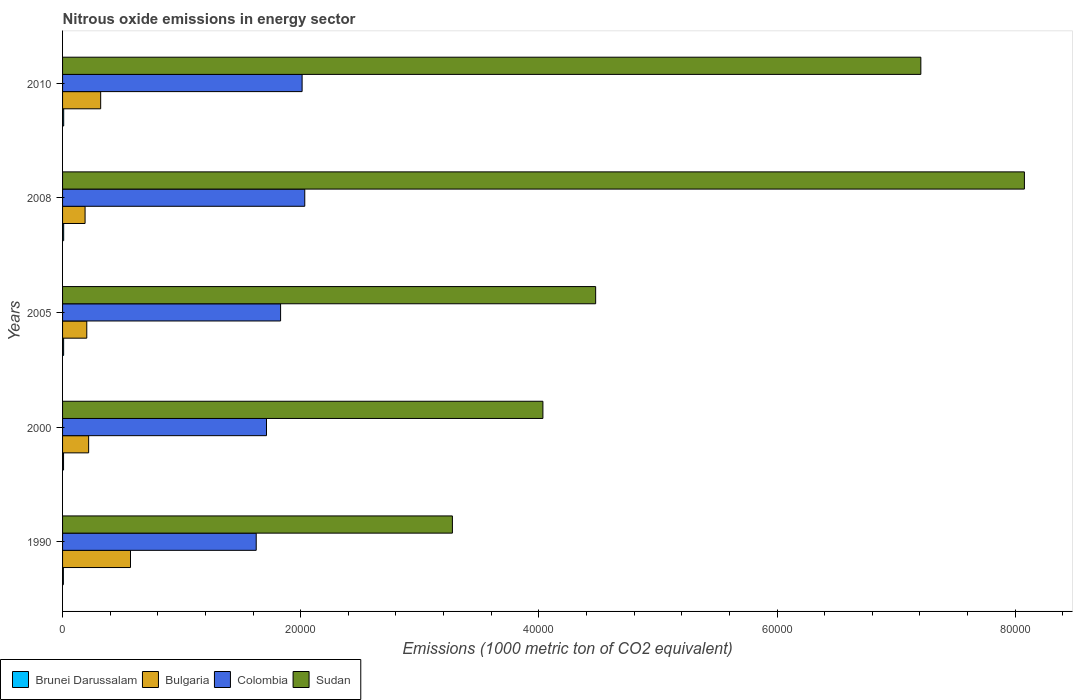How many bars are there on the 5th tick from the bottom?
Provide a short and direct response. 4. What is the amount of nitrous oxide emitted in Brunei Darussalam in 2005?
Provide a short and direct response. 88.9. Across all years, what is the maximum amount of nitrous oxide emitted in Colombia?
Provide a succinct answer. 2.03e+04. Across all years, what is the minimum amount of nitrous oxide emitted in Sudan?
Provide a succinct answer. 3.27e+04. In which year was the amount of nitrous oxide emitted in Colombia minimum?
Provide a succinct answer. 1990. What is the total amount of nitrous oxide emitted in Colombia in the graph?
Provide a succinct answer. 9.22e+04. What is the difference between the amount of nitrous oxide emitted in Sudan in 2000 and that in 2010?
Give a very brief answer. -3.17e+04. What is the difference between the amount of nitrous oxide emitted in Sudan in 1990 and the amount of nitrous oxide emitted in Colombia in 2008?
Make the answer very short. 1.24e+04. What is the average amount of nitrous oxide emitted in Sudan per year?
Give a very brief answer. 5.41e+04. In the year 1990, what is the difference between the amount of nitrous oxide emitted in Sudan and amount of nitrous oxide emitted in Colombia?
Provide a succinct answer. 1.65e+04. What is the ratio of the amount of nitrous oxide emitted in Sudan in 2005 to that in 2010?
Provide a succinct answer. 0.62. Is the difference between the amount of nitrous oxide emitted in Sudan in 2008 and 2010 greater than the difference between the amount of nitrous oxide emitted in Colombia in 2008 and 2010?
Your answer should be compact. Yes. What is the difference between the highest and the second highest amount of nitrous oxide emitted in Bulgaria?
Provide a succinct answer. 2505.6. What is the difference between the highest and the lowest amount of nitrous oxide emitted in Colombia?
Your answer should be very brief. 4077.5. Is it the case that in every year, the sum of the amount of nitrous oxide emitted in Bulgaria and amount of nitrous oxide emitted in Colombia is greater than the sum of amount of nitrous oxide emitted in Sudan and amount of nitrous oxide emitted in Brunei Darussalam?
Ensure brevity in your answer.  No. What does the 1st bar from the top in 2005 represents?
Keep it short and to the point. Sudan. What does the 4th bar from the bottom in 2000 represents?
Offer a very short reply. Sudan. Is it the case that in every year, the sum of the amount of nitrous oxide emitted in Colombia and amount of nitrous oxide emitted in Sudan is greater than the amount of nitrous oxide emitted in Bulgaria?
Keep it short and to the point. Yes. How many bars are there?
Keep it short and to the point. 20. Are all the bars in the graph horizontal?
Ensure brevity in your answer.  Yes. Does the graph contain any zero values?
Your response must be concise. No. Where does the legend appear in the graph?
Your response must be concise. Bottom left. What is the title of the graph?
Your response must be concise. Nitrous oxide emissions in energy sector. What is the label or title of the X-axis?
Your response must be concise. Emissions (1000 metric ton of CO2 equivalent). What is the label or title of the Y-axis?
Provide a short and direct response. Years. What is the Emissions (1000 metric ton of CO2 equivalent) in Brunei Darussalam in 1990?
Give a very brief answer. 67.9. What is the Emissions (1000 metric ton of CO2 equivalent) in Bulgaria in 1990?
Provide a succinct answer. 5705.4. What is the Emissions (1000 metric ton of CO2 equivalent) of Colombia in 1990?
Your answer should be very brief. 1.63e+04. What is the Emissions (1000 metric ton of CO2 equivalent) of Sudan in 1990?
Make the answer very short. 3.27e+04. What is the Emissions (1000 metric ton of CO2 equivalent) of Brunei Darussalam in 2000?
Give a very brief answer. 82.7. What is the Emissions (1000 metric ton of CO2 equivalent) of Bulgaria in 2000?
Your answer should be very brief. 2189.9. What is the Emissions (1000 metric ton of CO2 equivalent) of Colombia in 2000?
Offer a very short reply. 1.71e+04. What is the Emissions (1000 metric ton of CO2 equivalent) in Sudan in 2000?
Offer a terse response. 4.03e+04. What is the Emissions (1000 metric ton of CO2 equivalent) of Brunei Darussalam in 2005?
Make the answer very short. 88.9. What is the Emissions (1000 metric ton of CO2 equivalent) of Bulgaria in 2005?
Keep it short and to the point. 2033.5. What is the Emissions (1000 metric ton of CO2 equivalent) in Colombia in 2005?
Make the answer very short. 1.83e+04. What is the Emissions (1000 metric ton of CO2 equivalent) of Sudan in 2005?
Offer a very short reply. 4.48e+04. What is the Emissions (1000 metric ton of CO2 equivalent) in Brunei Darussalam in 2008?
Provide a short and direct response. 92.7. What is the Emissions (1000 metric ton of CO2 equivalent) of Bulgaria in 2008?
Your response must be concise. 1890.6. What is the Emissions (1000 metric ton of CO2 equivalent) in Colombia in 2008?
Ensure brevity in your answer.  2.03e+04. What is the Emissions (1000 metric ton of CO2 equivalent) in Sudan in 2008?
Your answer should be very brief. 8.08e+04. What is the Emissions (1000 metric ton of CO2 equivalent) of Brunei Darussalam in 2010?
Your answer should be very brief. 94.1. What is the Emissions (1000 metric ton of CO2 equivalent) in Bulgaria in 2010?
Make the answer very short. 3199.8. What is the Emissions (1000 metric ton of CO2 equivalent) of Colombia in 2010?
Keep it short and to the point. 2.01e+04. What is the Emissions (1000 metric ton of CO2 equivalent) in Sudan in 2010?
Offer a terse response. 7.21e+04. Across all years, what is the maximum Emissions (1000 metric ton of CO2 equivalent) of Brunei Darussalam?
Your response must be concise. 94.1. Across all years, what is the maximum Emissions (1000 metric ton of CO2 equivalent) of Bulgaria?
Give a very brief answer. 5705.4. Across all years, what is the maximum Emissions (1000 metric ton of CO2 equivalent) in Colombia?
Provide a short and direct response. 2.03e+04. Across all years, what is the maximum Emissions (1000 metric ton of CO2 equivalent) of Sudan?
Keep it short and to the point. 8.08e+04. Across all years, what is the minimum Emissions (1000 metric ton of CO2 equivalent) of Brunei Darussalam?
Keep it short and to the point. 67.9. Across all years, what is the minimum Emissions (1000 metric ton of CO2 equivalent) of Bulgaria?
Offer a very short reply. 1890.6. Across all years, what is the minimum Emissions (1000 metric ton of CO2 equivalent) in Colombia?
Provide a succinct answer. 1.63e+04. Across all years, what is the minimum Emissions (1000 metric ton of CO2 equivalent) in Sudan?
Your answer should be very brief. 3.27e+04. What is the total Emissions (1000 metric ton of CO2 equivalent) in Brunei Darussalam in the graph?
Provide a short and direct response. 426.3. What is the total Emissions (1000 metric ton of CO2 equivalent) in Bulgaria in the graph?
Your answer should be compact. 1.50e+04. What is the total Emissions (1000 metric ton of CO2 equivalent) of Colombia in the graph?
Make the answer very short. 9.22e+04. What is the total Emissions (1000 metric ton of CO2 equivalent) in Sudan in the graph?
Offer a very short reply. 2.71e+05. What is the difference between the Emissions (1000 metric ton of CO2 equivalent) in Brunei Darussalam in 1990 and that in 2000?
Your answer should be very brief. -14.8. What is the difference between the Emissions (1000 metric ton of CO2 equivalent) in Bulgaria in 1990 and that in 2000?
Your answer should be compact. 3515.5. What is the difference between the Emissions (1000 metric ton of CO2 equivalent) of Colombia in 1990 and that in 2000?
Make the answer very short. -864.4. What is the difference between the Emissions (1000 metric ton of CO2 equivalent) in Sudan in 1990 and that in 2000?
Make the answer very short. -7600.6. What is the difference between the Emissions (1000 metric ton of CO2 equivalent) in Brunei Darussalam in 1990 and that in 2005?
Give a very brief answer. -21. What is the difference between the Emissions (1000 metric ton of CO2 equivalent) in Bulgaria in 1990 and that in 2005?
Provide a short and direct response. 3671.9. What is the difference between the Emissions (1000 metric ton of CO2 equivalent) of Colombia in 1990 and that in 2005?
Ensure brevity in your answer.  -2047.6. What is the difference between the Emissions (1000 metric ton of CO2 equivalent) of Sudan in 1990 and that in 2005?
Keep it short and to the point. -1.20e+04. What is the difference between the Emissions (1000 metric ton of CO2 equivalent) of Brunei Darussalam in 1990 and that in 2008?
Offer a terse response. -24.8. What is the difference between the Emissions (1000 metric ton of CO2 equivalent) in Bulgaria in 1990 and that in 2008?
Ensure brevity in your answer.  3814.8. What is the difference between the Emissions (1000 metric ton of CO2 equivalent) in Colombia in 1990 and that in 2008?
Provide a succinct answer. -4077.5. What is the difference between the Emissions (1000 metric ton of CO2 equivalent) in Sudan in 1990 and that in 2008?
Give a very brief answer. -4.80e+04. What is the difference between the Emissions (1000 metric ton of CO2 equivalent) of Brunei Darussalam in 1990 and that in 2010?
Provide a succinct answer. -26.2. What is the difference between the Emissions (1000 metric ton of CO2 equivalent) of Bulgaria in 1990 and that in 2010?
Your response must be concise. 2505.6. What is the difference between the Emissions (1000 metric ton of CO2 equivalent) in Colombia in 1990 and that in 2010?
Your answer should be very brief. -3854.4. What is the difference between the Emissions (1000 metric ton of CO2 equivalent) of Sudan in 1990 and that in 2010?
Offer a terse response. -3.93e+04. What is the difference between the Emissions (1000 metric ton of CO2 equivalent) of Brunei Darussalam in 2000 and that in 2005?
Make the answer very short. -6.2. What is the difference between the Emissions (1000 metric ton of CO2 equivalent) in Bulgaria in 2000 and that in 2005?
Give a very brief answer. 156.4. What is the difference between the Emissions (1000 metric ton of CO2 equivalent) of Colombia in 2000 and that in 2005?
Offer a terse response. -1183.2. What is the difference between the Emissions (1000 metric ton of CO2 equivalent) in Sudan in 2000 and that in 2005?
Your answer should be very brief. -4429.1. What is the difference between the Emissions (1000 metric ton of CO2 equivalent) in Bulgaria in 2000 and that in 2008?
Ensure brevity in your answer.  299.3. What is the difference between the Emissions (1000 metric ton of CO2 equivalent) of Colombia in 2000 and that in 2008?
Keep it short and to the point. -3213.1. What is the difference between the Emissions (1000 metric ton of CO2 equivalent) of Sudan in 2000 and that in 2008?
Offer a very short reply. -4.04e+04. What is the difference between the Emissions (1000 metric ton of CO2 equivalent) of Brunei Darussalam in 2000 and that in 2010?
Your response must be concise. -11.4. What is the difference between the Emissions (1000 metric ton of CO2 equivalent) in Bulgaria in 2000 and that in 2010?
Provide a succinct answer. -1009.9. What is the difference between the Emissions (1000 metric ton of CO2 equivalent) of Colombia in 2000 and that in 2010?
Make the answer very short. -2990. What is the difference between the Emissions (1000 metric ton of CO2 equivalent) of Sudan in 2000 and that in 2010?
Give a very brief answer. -3.17e+04. What is the difference between the Emissions (1000 metric ton of CO2 equivalent) in Bulgaria in 2005 and that in 2008?
Your answer should be compact. 142.9. What is the difference between the Emissions (1000 metric ton of CO2 equivalent) in Colombia in 2005 and that in 2008?
Ensure brevity in your answer.  -2029.9. What is the difference between the Emissions (1000 metric ton of CO2 equivalent) in Sudan in 2005 and that in 2008?
Make the answer very short. -3.60e+04. What is the difference between the Emissions (1000 metric ton of CO2 equivalent) in Bulgaria in 2005 and that in 2010?
Your answer should be very brief. -1166.3. What is the difference between the Emissions (1000 metric ton of CO2 equivalent) in Colombia in 2005 and that in 2010?
Give a very brief answer. -1806.8. What is the difference between the Emissions (1000 metric ton of CO2 equivalent) in Sudan in 2005 and that in 2010?
Ensure brevity in your answer.  -2.73e+04. What is the difference between the Emissions (1000 metric ton of CO2 equivalent) of Brunei Darussalam in 2008 and that in 2010?
Offer a very short reply. -1.4. What is the difference between the Emissions (1000 metric ton of CO2 equivalent) of Bulgaria in 2008 and that in 2010?
Provide a short and direct response. -1309.2. What is the difference between the Emissions (1000 metric ton of CO2 equivalent) in Colombia in 2008 and that in 2010?
Your answer should be compact. 223.1. What is the difference between the Emissions (1000 metric ton of CO2 equivalent) of Sudan in 2008 and that in 2010?
Provide a succinct answer. 8696.2. What is the difference between the Emissions (1000 metric ton of CO2 equivalent) of Brunei Darussalam in 1990 and the Emissions (1000 metric ton of CO2 equivalent) of Bulgaria in 2000?
Ensure brevity in your answer.  -2122. What is the difference between the Emissions (1000 metric ton of CO2 equivalent) of Brunei Darussalam in 1990 and the Emissions (1000 metric ton of CO2 equivalent) of Colombia in 2000?
Give a very brief answer. -1.71e+04. What is the difference between the Emissions (1000 metric ton of CO2 equivalent) of Brunei Darussalam in 1990 and the Emissions (1000 metric ton of CO2 equivalent) of Sudan in 2000?
Make the answer very short. -4.03e+04. What is the difference between the Emissions (1000 metric ton of CO2 equivalent) in Bulgaria in 1990 and the Emissions (1000 metric ton of CO2 equivalent) in Colombia in 2000?
Make the answer very short. -1.14e+04. What is the difference between the Emissions (1000 metric ton of CO2 equivalent) of Bulgaria in 1990 and the Emissions (1000 metric ton of CO2 equivalent) of Sudan in 2000?
Your answer should be compact. -3.46e+04. What is the difference between the Emissions (1000 metric ton of CO2 equivalent) in Colombia in 1990 and the Emissions (1000 metric ton of CO2 equivalent) in Sudan in 2000?
Provide a short and direct response. -2.41e+04. What is the difference between the Emissions (1000 metric ton of CO2 equivalent) of Brunei Darussalam in 1990 and the Emissions (1000 metric ton of CO2 equivalent) of Bulgaria in 2005?
Your answer should be compact. -1965.6. What is the difference between the Emissions (1000 metric ton of CO2 equivalent) of Brunei Darussalam in 1990 and the Emissions (1000 metric ton of CO2 equivalent) of Colombia in 2005?
Your response must be concise. -1.82e+04. What is the difference between the Emissions (1000 metric ton of CO2 equivalent) of Brunei Darussalam in 1990 and the Emissions (1000 metric ton of CO2 equivalent) of Sudan in 2005?
Keep it short and to the point. -4.47e+04. What is the difference between the Emissions (1000 metric ton of CO2 equivalent) in Bulgaria in 1990 and the Emissions (1000 metric ton of CO2 equivalent) in Colombia in 2005?
Make the answer very short. -1.26e+04. What is the difference between the Emissions (1000 metric ton of CO2 equivalent) of Bulgaria in 1990 and the Emissions (1000 metric ton of CO2 equivalent) of Sudan in 2005?
Offer a terse response. -3.91e+04. What is the difference between the Emissions (1000 metric ton of CO2 equivalent) of Colombia in 1990 and the Emissions (1000 metric ton of CO2 equivalent) of Sudan in 2005?
Your answer should be very brief. -2.85e+04. What is the difference between the Emissions (1000 metric ton of CO2 equivalent) in Brunei Darussalam in 1990 and the Emissions (1000 metric ton of CO2 equivalent) in Bulgaria in 2008?
Provide a succinct answer. -1822.7. What is the difference between the Emissions (1000 metric ton of CO2 equivalent) of Brunei Darussalam in 1990 and the Emissions (1000 metric ton of CO2 equivalent) of Colombia in 2008?
Ensure brevity in your answer.  -2.03e+04. What is the difference between the Emissions (1000 metric ton of CO2 equivalent) in Brunei Darussalam in 1990 and the Emissions (1000 metric ton of CO2 equivalent) in Sudan in 2008?
Give a very brief answer. -8.07e+04. What is the difference between the Emissions (1000 metric ton of CO2 equivalent) in Bulgaria in 1990 and the Emissions (1000 metric ton of CO2 equivalent) in Colombia in 2008?
Your response must be concise. -1.46e+04. What is the difference between the Emissions (1000 metric ton of CO2 equivalent) of Bulgaria in 1990 and the Emissions (1000 metric ton of CO2 equivalent) of Sudan in 2008?
Ensure brevity in your answer.  -7.51e+04. What is the difference between the Emissions (1000 metric ton of CO2 equivalent) in Colombia in 1990 and the Emissions (1000 metric ton of CO2 equivalent) in Sudan in 2008?
Make the answer very short. -6.45e+04. What is the difference between the Emissions (1000 metric ton of CO2 equivalent) of Brunei Darussalam in 1990 and the Emissions (1000 metric ton of CO2 equivalent) of Bulgaria in 2010?
Your answer should be compact. -3131.9. What is the difference between the Emissions (1000 metric ton of CO2 equivalent) in Brunei Darussalam in 1990 and the Emissions (1000 metric ton of CO2 equivalent) in Colombia in 2010?
Provide a succinct answer. -2.00e+04. What is the difference between the Emissions (1000 metric ton of CO2 equivalent) of Brunei Darussalam in 1990 and the Emissions (1000 metric ton of CO2 equivalent) of Sudan in 2010?
Provide a succinct answer. -7.20e+04. What is the difference between the Emissions (1000 metric ton of CO2 equivalent) of Bulgaria in 1990 and the Emissions (1000 metric ton of CO2 equivalent) of Colombia in 2010?
Provide a succinct answer. -1.44e+04. What is the difference between the Emissions (1000 metric ton of CO2 equivalent) of Bulgaria in 1990 and the Emissions (1000 metric ton of CO2 equivalent) of Sudan in 2010?
Your answer should be very brief. -6.64e+04. What is the difference between the Emissions (1000 metric ton of CO2 equivalent) in Colombia in 1990 and the Emissions (1000 metric ton of CO2 equivalent) in Sudan in 2010?
Your answer should be compact. -5.58e+04. What is the difference between the Emissions (1000 metric ton of CO2 equivalent) in Brunei Darussalam in 2000 and the Emissions (1000 metric ton of CO2 equivalent) in Bulgaria in 2005?
Provide a short and direct response. -1950.8. What is the difference between the Emissions (1000 metric ton of CO2 equivalent) of Brunei Darussalam in 2000 and the Emissions (1000 metric ton of CO2 equivalent) of Colombia in 2005?
Make the answer very short. -1.82e+04. What is the difference between the Emissions (1000 metric ton of CO2 equivalent) of Brunei Darussalam in 2000 and the Emissions (1000 metric ton of CO2 equivalent) of Sudan in 2005?
Your answer should be compact. -4.47e+04. What is the difference between the Emissions (1000 metric ton of CO2 equivalent) in Bulgaria in 2000 and the Emissions (1000 metric ton of CO2 equivalent) in Colombia in 2005?
Make the answer very short. -1.61e+04. What is the difference between the Emissions (1000 metric ton of CO2 equivalent) in Bulgaria in 2000 and the Emissions (1000 metric ton of CO2 equivalent) in Sudan in 2005?
Your answer should be very brief. -4.26e+04. What is the difference between the Emissions (1000 metric ton of CO2 equivalent) of Colombia in 2000 and the Emissions (1000 metric ton of CO2 equivalent) of Sudan in 2005?
Your response must be concise. -2.76e+04. What is the difference between the Emissions (1000 metric ton of CO2 equivalent) in Brunei Darussalam in 2000 and the Emissions (1000 metric ton of CO2 equivalent) in Bulgaria in 2008?
Make the answer very short. -1807.9. What is the difference between the Emissions (1000 metric ton of CO2 equivalent) in Brunei Darussalam in 2000 and the Emissions (1000 metric ton of CO2 equivalent) in Colombia in 2008?
Offer a terse response. -2.03e+04. What is the difference between the Emissions (1000 metric ton of CO2 equivalent) in Brunei Darussalam in 2000 and the Emissions (1000 metric ton of CO2 equivalent) in Sudan in 2008?
Your response must be concise. -8.07e+04. What is the difference between the Emissions (1000 metric ton of CO2 equivalent) of Bulgaria in 2000 and the Emissions (1000 metric ton of CO2 equivalent) of Colombia in 2008?
Offer a very short reply. -1.81e+04. What is the difference between the Emissions (1000 metric ton of CO2 equivalent) of Bulgaria in 2000 and the Emissions (1000 metric ton of CO2 equivalent) of Sudan in 2008?
Keep it short and to the point. -7.86e+04. What is the difference between the Emissions (1000 metric ton of CO2 equivalent) of Colombia in 2000 and the Emissions (1000 metric ton of CO2 equivalent) of Sudan in 2008?
Your answer should be compact. -6.36e+04. What is the difference between the Emissions (1000 metric ton of CO2 equivalent) in Brunei Darussalam in 2000 and the Emissions (1000 metric ton of CO2 equivalent) in Bulgaria in 2010?
Give a very brief answer. -3117.1. What is the difference between the Emissions (1000 metric ton of CO2 equivalent) of Brunei Darussalam in 2000 and the Emissions (1000 metric ton of CO2 equivalent) of Colombia in 2010?
Your answer should be compact. -2.00e+04. What is the difference between the Emissions (1000 metric ton of CO2 equivalent) of Brunei Darussalam in 2000 and the Emissions (1000 metric ton of CO2 equivalent) of Sudan in 2010?
Your response must be concise. -7.20e+04. What is the difference between the Emissions (1000 metric ton of CO2 equivalent) in Bulgaria in 2000 and the Emissions (1000 metric ton of CO2 equivalent) in Colombia in 2010?
Offer a very short reply. -1.79e+04. What is the difference between the Emissions (1000 metric ton of CO2 equivalent) of Bulgaria in 2000 and the Emissions (1000 metric ton of CO2 equivalent) of Sudan in 2010?
Keep it short and to the point. -6.99e+04. What is the difference between the Emissions (1000 metric ton of CO2 equivalent) in Colombia in 2000 and the Emissions (1000 metric ton of CO2 equivalent) in Sudan in 2010?
Your answer should be very brief. -5.50e+04. What is the difference between the Emissions (1000 metric ton of CO2 equivalent) of Brunei Darussalam in 2005 and the Emissions (1000 metric ton of CO2 equivalent) of Bulgaria in 2008?
Your response must be concise. -1801.7. What is the difference between the Emissions (1000 metric ton of CO2 equivalent) of Brunei Darussalam in 2005 and the Emissions (1000 metric ton of CO2 equivalent) of Colombia in 2008?
Keep it short and to the point. -2.03e+04. What is the difference between the Emissions (1000 metric ton of CO2 equivalent) of Brunei Darussalam in 2005 and the Emissions (1000 metric ton of CO2 equivalent) of Sudan in 2008?
Your answer should be compact. -8.07e+04. What is the difference between the Emissions (1000 metric ton of CO2 equivalent) in Bulgaria in 2005 and the Emissions (1000 metric ton of CO2 equivalent) in Colombia in 2008?
Your response must be concise. -1.83e+04. What is the difference between the Emissions (1000 metric ton of CO2 equivalent) in Bulgaria in 2005 and the Emissions (1000 metric ton of CO2 equivalent) in Sudan in 2008?
Provide a succinct answer. -7.87e+04. What is the difference between the Emissions (1000 metric ton of CO2 equivalent) in Colombia in 2005 and the Emissions (1000 metric ton of CO2 equivalent) in Sudan in 2008?
Ensure brevity in your answer.  -6.25e+04. What is the difference between the Emissions (1000 metric ton of CO2 equivalent) of Brunei Darussalam in 2005 and the Emissions (1000 metric ton of CO2 equivalent) of Bulgaria in 2010?
Your answer should be compact. -3110.9. What is the difference between the Emissions (1000 metric ton of CO2 equivalent) of Brunei Darussalam in 2005 and the Emissions (1000 metric ton of CO2 equivalent) of Colombia in 2010?
Offer a terse response. -2.00e+04. What is the difference between the Emissions (1000 metric ton of CO2 equivalent) in Brunei Darussalam in 2005 and the Emissions (1000 metric ton of CO2 equivalent) in Sudan in 2010?
Provide a short and direct response. -7.20e+04. What is the difference between the Emissions (1000 metric ton of CO2 equivalent) of Bulgaria in 2005 and the Emissions (1000 metric ton of CO2 equivalent) of Colombia in 2010?
Your response must be concise. -1.81e+04. What is the difference between the Emissions (1000 metric ton of CO2 equivalent) in Bulgaria in 2005 and the Emissions (1000 metric ton of CO2 equivalent) in Sudan in 2010?
Keep it short and to the point. -7.00e+04. What is the difference between the Emissions (1000 metric ton of CO2 equivalent) of Colombia in 2005 and the Emissions (1000 metric ton of CO2 equivalent) of Sudan in 2010?
Keep it short and to the point. -5.38e+04. What is the difference between the Emissions (1000 metric ton of CO2 equivalent) in Brunei Darussalam in 2008 and the Emissions (1000 metric ton of CO2 equivalent) in Bulgaria in 2010?
Offer a terse response. -3107.1. What is the difference between the Emissions (1000 metric ton of CO2 equivalent) of Brunei Darussalam in 2008 and the Emissions (1000 metric ton of CO2 equivalent) of Colombia in 2010?
Give a very brief answer. -2.00e+04. What is the difference between the Emissions (1000 metric ton of CO2 equivalent) of Brunei Darussalam in 2008 and the Emissions (1000 metric ton of CO2 equivalent) of Sudan in 2010?
Keep it short and to the point. -7.20e+04. What is the difference between the Emissions (1000 metric ton of CO2 equivalent) in Bulgaria in 2008 and the Emissions (1000 metric ton of CO2 equivalent) in Colombia in 2010?
Your answer should be compact. -1.82e+04. What is the difference between the Emissions (1000 metric ton of CO2 equivalent) in Bulgaria in 2008 and the Emissions (1000 metric ton of CO2 equivalent) in Sudan in 2010?
Your response must be concise. -7.02e+04. What is the difference between the Emissions (1000 metric ton of CO2 equivalent) in Colombia in 2008 and the Emissions (1000 metric ton of CO2 equivalent) in Sudan in 2010?
Make the answer very short. -5.17e+04. What is the average Emissions (1000 metric ton of CO2 equivalent) in Brunei Darussalam per year?
Offer a very short reply. 85.26. What is the average Emissions (1000 metric ton of CO2 equivalent) in Bulgaria per year?
Provide a succinct answer. 3003.84. What is the average Emissions (1000 metric ton of CO2 equivalent) of Colombia per year?
Your response must be concise. 1.84e+04. What is the average Emissions (1000 metric ton of CO2 equivalent) of Sudan per year?
Offer a terse response. 5.41e+04. In the year 1990, what is the difference between the Emissions (1000 metric ton of CO2 equivalent) in Brunei Darussalam and Emissions (1000 metric ton of CO2 equivalent) in Bulgaria?
Give a very brief answer. -5637.5. In the year 1990, what is the difference between the Emissions (1000 metric ton of CO2 equivalent) of Brunei Darussalam and Emissions (1000 metric ton of CO2 equivalent) of Colombia?
Keep it short and to the point. -1.62e+04. In the year 1990, what is the difference between the Emissions (1000 metric ton of CO2 equivalent) of Brunei Darussalam and Emissions (1000 metric ton of CO2 equivalent) of Sudan?
Provide a short and direct response. -3.27e+04. In the year 1990, what is the difference between the Emissions (1000 metric ton of CO2 equivalent) of Bulgaria and Emissions (1000 metric ton of CO2 equivalent) of Colombia?
Ensure brevity in your answer.  -1.06e+04. In the year 1990, what is the difference between the Emissions (1000 metric ton of CO2 equivalent) of Bulgaria and Emissions (1000 metric ton of CO2 equivalent) of Sudan?
Make the answer very short. -2.70e+04. In the year 1990, what is the difference between the Emissions (1000 metric ton of CO2 equivalent) in Colombia and Emissions (1000 metric ton of CO2 equivalent) in Sudan?
Keep it short and to the point. -1.65e+04. In the year 2000, what is the difference between the Emissions (1000 metric ton of CO2 equivalent) in Brunei Darussalam and Emissions (1000 metric ton of CO2 equivalent) in Bulgaria?
Your response must be concise. -2107.2. In the year 2000, what is the difference between the Emissions (1000 metric ton of CO2 equivalent) in Brunei Darussalam and Emissions (1000 metric ton of CO2 equivalent) in Colombia?
Make the answer very short. -1.70e+04. In the year 2000, what is the difference between the Emissions (1000 metric ton of CO2 equivalent) in Brunei Darussalam and Emissions (1000 metric ton of CO2 equivalent) in Sudan?
Keep it short and to the point. -4.03e+04. In the year 2000, what is the difference between the Emissions (1000 metric ton of CO2 equivalent) in Bulgaria and Emissions (1000 metric ton of CO2 equivalent) in Colombia?
Provide a succinct answer. -1.49e+04. In the year 2000, what is the difference between the Emissions (1000 metric ton of CO2 equivalent) of Bulgaria and Emissions (1000 metric ton of CO2 equivalent) of Sudan?
Offer a terse response. -3.81e+04. In the year 2000, what is the difference between the Emissions (1000 metric ton of CO2 equivalent) of Colombia and Emissions (1000 metric ton of CO2 equivalent) of Sudan?
Give a very brief answer. -2.32e+04. In the year 2005, what is the difference between the Emissions (1000 metric ton of CO2 equivalent) of Brunei Darussalam and Emissions (1000 metric ton of CO2 equivalent) of Bulgaria?
Provide a succinct answer. -1944.6. In the year 2005, what is the difference between the Emissions (1000 metric ton of CO2 equivalent) in Brunei Darussalam and Emissions (1000 metric ton of CO2 equivalent) in Colombia?
Make the answer very short. -1.82e+04. In the year 2005, what is the difference between the Emissions (1000 metric ton of CO2 equivalent) in Brunei Darussalam and Emissions (1000 metric ton of CO2 equivalent) in Sudan?
Your answer should be very brief. -4.47e+04. In the year 2005, what is the difference between the Emissions (1000 metric ton of CO2 equivalent) of Bulgaria and Emissions (1000 metric ton of CO2 equivalent) of Colombia?
Make the answer very short. -1.63e+04. In the year 2005, what is the difference between the Emissions (1000 metric ton of CO2 equivalent) of Bulgaria and Emissions (1000 metric ton of CO2 equivalent) of Sudan?
Your answer should be very brief. -4.27e+04. In the year 2005, what is the difference between the Emissions (1000 metric ton of CO2 equivalent) of Colombia and Emissions (1000 metric ton of CO2 equivalent) of Sudan?
Offer a terse response. -2.65e+04. In the year 2008, what is the difference between the Emissions (1000 metric ton of CO2 equivalent) in Brunei Darussalam and Emissions (1000 metric ton of CO2 equivalent) in Bulgaria?
Give a very brief answer. -1797.9. In the year 2008, what is the difference between the Emissions (1000 metric ton of CO2 equivalent) in Brunei Darussalam and Emissions (1000 metric ton of CO2 equivalent) in Colombia?
Keep it short and to the point. -2.02e+04. In the year 2008, what is the difference between the Emissions (1000 metric ton of CO2 equivalent) in Brunei Darussalam and Emissions (1000 metric ton of CO2 equivalent) in Sudan?
Offer a terse response. -8.07e+04. In the year 2008, what is the difference between the Emissions (1000 metric ton of CO2 equivalent) of Bulgaria and Emissions (1000 metric ton of CO2 equivalent) of Colombia?
Keep it short and to the point. -1.84e+04. In the year 2008, what is the difference between the Emissions (1000 metric ton of CO2 equivalent) of Bulgaria and Emissions (1000 metric ton of CO2 equivalent) of Sudan?
Ensure brevity in your answer.  -7.89e+04. In the year 2008, what is the difference between the Emissions (1000 metric ton of CO2 equivalent) in Colombia and Emissions (1000 metric ton of CO2 equivalent) in Sudan?
Ensure brevity in your answer.  -6.04e+04. In the year 2010, what is the difference between the Emissions (1000 metric ton of CO2 equivalent) of Brunei Darussalam and Emissions (1000 metric ton of CO2 equivalent) of Bulgaria?
Offer a very short reply. -3105.7. In the year 2010, what is the difference between the Emissions (1000 metric ton of CO2 equivalent) in Brunei Darussalam and Emissions (1000 metric ton of CO2 equivalent) in Colombia?
Keep it short and to the point. -2.00e+04. In the year 2010, what is the difference between the Emissions (1000 metric ton of CO2 equivalent) of Brunei Darussalam and Emissions (1000 metric ton of CO2 equivalent) of Sudan?
Make the answer very short. -7.20e+04. In the year 2010, what is the difference between the Emissions (1000 metric ton of CO2 equivalent) of Bulgaria and Emissions (1000 metric ton of CO2 equivalent) of Colombia?
Keep it short and to the point. -1.69e+04. In the year 2010, what is the difference between the Emissions (1000 metric ton of CO2 equivalent) in Bulgaria and Emissions (1000 metric ton of CO2 equivalent) in Sudan?
Provide a succinct answer. -6.89e+04. In the year 2010, what is the difference between the Emissions (1000 metric ton of CO2 equivalent) in Colombia and Emissions (1000 metric ton of CO2 equivalent) in Sudan?
Give a very brief answer. -5.20e+04. What is the ratio of the Emissions (1000 metric ton of CO2 equivalent) in Brunei Darussalam in 1990 to that in 2000?
Make the answer very short. 0.82. What is the ratio of the Emissions (1000 metric ton of CO2 equivalent) of Bulgaria in 1990 to that in 2000?
Make the answer very short. 2.61. What is the ratio of the Emissions (1000 metric ton of CO2 equivalent) in Colombia in 1990 to that in 2000?
Give a very brief answer. 0.95. What is the ratio of the Emissions (1000 metric ton of CO2 equivalent) of Sudan in 1990 to that in 2000?
Offer a terse response. 0.81. What is the ratio of the Emissions (1000 metric ton of CO2 equivalent) of Brunei Darussalam in 1990 to that in 2005?
Ensure brevity in your answer.  0.76. What is the ratio of the Emissions (1000 metric ton of CO2 equivalent) in Bulgaria in 1990 to that in 2005?
Provide a short and direct response. 2.81. What is the ratio of the Emissions (1000 metric ton of CO2 equivalent) in Colombia in 1990 to that in 2005?
Offer a very short reply. 0.89. What is the ratio of the Emissions (1000 metric ton of CO2 equivalent) in Sudan in 1990 to that in 2005?
Ensure brevity in your answer.  0.73. What is the ratio of the Emissions (1000 metric ton of CO2 equivalent) of Brunei Darussalam in 1990 to that in 2008?
Give a very brief answer. 0.73. What is the ratio of the Emissions (1000 metric ton of CO2 equivalent) in Bulgaria in 1990 to that in 2008?
Keep it short and to the point. 3.02. What is the ratio of the Emissions (1000 metric ton of CO2 equivalent) of Colombia in 1990 to that in 2008?
Make the answer very short. 0.8. What is the ratio of the Emissions (1000 metric ton of CO2 equivalent) in Sudan in 1990 to that in 2008?
Provide a succinct answer. 0.41. What is the ratio of the Emissions (1000 metric ton of CO2 equivalent) in Brunei Darussalam in 1990 to that in 2010?
Your answer should be very brief. 0.72. What is the ratio of the Emissions (1000 metric ton of CO2 equivalent) of Bulgaria in 1990 to that in 2010?
Offer a terse response. 1.78. What is the ratio of the Emissions (1000 metric ton of CO2 equivalent) in Colombia in 1990 to that in 2010?
Give a very brief answer. 0.81. What is the ratio of the Emissions (1000 metric ton of CO2 equivalent) in Sudan in 1990 to that in 2010?
Ensure brevity in your answer.  0.45. What is the ratio of the Emissions (1000 metric ton of CO2 equivalent) of Brunei Darussalam in 2000 to that in 2005?
Provide a succinct answer. 0.93. What is the ratio of the Emissions (1000 metric ton of CO2 equivalent) in Colombia in 2000 to that in 2005?
Your response must be concise. 0.94. What is the ratio of the Emissions (1000 metric ton of CO2 equivalent) of Sudan in 2000 to that in 2005?
Offer a very short reply. 0.9. What is the ratio of the Emissions (1000 metric ton of CO2 equivalent) in Brunei Darussalam in 2000 to that in 2008?
Offer a terse response. 0.89. What is the ratio of the Emissions (1000 metric ton of CO2 equivalent) of Bulgaria in 2000 to that in 2008?
Your answer should be compact. 1.16. What is the ratio of the Emissions (1000 metric ton of CO2 equivalent) of Colombia in 2000 to that in 2008?
Provide a succinct answer. 0.84. What is the ratio of the Emissions (1000 metric ton of CO2 equivalent) of Sudan in 2000 to that in 2008?
Provide a succinct answer. 0.5. What is the ratio of the Emissions (1000 metric ton of CO2 equivalent) of Brunei Darussalam in 2000 to that in 2010?
Your response must be concise. 0.88. What is the ratio of the Emissions (1000 metric ton of CO2 equivalent) in Bulgaria in 2000 to that in 2010?
Provide a succinct answer. 0.68. What is the ratio of the Emissions (1000 metric ton of CO2 equivalent) of Colombia in 2000 to that in 2010?
Offer a terse response. 0.85. What is the ratio of the Emissions (1000 metric ton of CO2 equivalent) in Sudan in 2000 to that in 2010?
Keep it short and to the point. 0.56. What is the ratio of the Emissions (1000 metric ton of CO2 equivalent) of Bulgaria in 2005 to that in 2008?
Your answer should be very brief. 1.08. What is the ratio of the Emissions (1000 metric ton of CO2 equivalent) of Colombia in 2005 to that in 2008?
Ensure brevity in your answer.  0.9. What is the ratio of the Emissions (1000 metric ton of CO2 equivalent) of Sudan in 2005 to that in 2008?
Offer a terse response. 0.55. What is the ratio of the Emissions (1000 metric ton of CO2 equivalent) of Brunei Darussalam in 2005 to that in 2010?
Give a very brief answer. 0.94. What is the ratio of the Emissions (1000 metric ton of CO2 equivalent) in Bulgaria in 2005 to that in 2010?
Ensure brevity in your answer.  0.64. What is the ratio of the Emissions (1000 metric ton of CO2 equivalent) of Colombia in 2005 to that in 2010?
Keep it short and to the point. 0.91. What is the ratio of the Emissions (1000 metric ton of CO2 equivalent) in Sudan in 2005 to that in 2010?
Offer a terse response. 0.62. What is the ratio of the Emissions (1000 metric ton of CO2 equivalent) of Brunei Darussalam in 2008 to that in 2010?
Your answer should be compact. 0.99. What is the ratio of the Emissions (1000 metric ton of CO2 equivalent) of Bulgaria in 2008 to that in 2010?
Provide a succinct answer. 0.59. What is the ratio of the Emissions (1000 metric ton of CO2 equivalent) of Colombia in 2008 to that in 2010?
Make the answer very short. 1.01. What is the ratio of the Emissions (1000 metric ton of CO2 equivalent) of Sudan in 2008 to that in 2010?
Your response must be concise. 1.12. What is the difference between the highest and the second highest Emissions (1000 metric ton of CO2 equivalent) of Bulgaria?
Provide a short and direct response. 2505.6. What is the difference between the highest and the second highest Emissions (1000 metric ton of CO2 equivalent) of Colombia?
Your answer should be very brief. 223.1. What is the difference between the highest and the second highest Emissions (1000 metric ton of CO2 equivalent) of Sudan?
Offer a terse response. 8696.2. What is the difference between the highest and the lowest Emissions (1000 metric ton of CO2 equivalent) in Brunei Darussalam?
Keep it short and to the point. 26.2. What is the difference between the highest and the lowest Emissions (1000 metric ton of CO2 equivalent) in Bulgaria?
Your answer should be compact. 3814.8. What is the difference between the highest and the lowest Emissions (1000 metric ton of CO2 equivalent) of Colombia?
Provide a short and direct response. 4077.5. What is the difference between the highest and the lowest Emissions (1000 metric ton of CO2 equivalent) in Sudan?
Your response must be concise. 4.80e+04. 